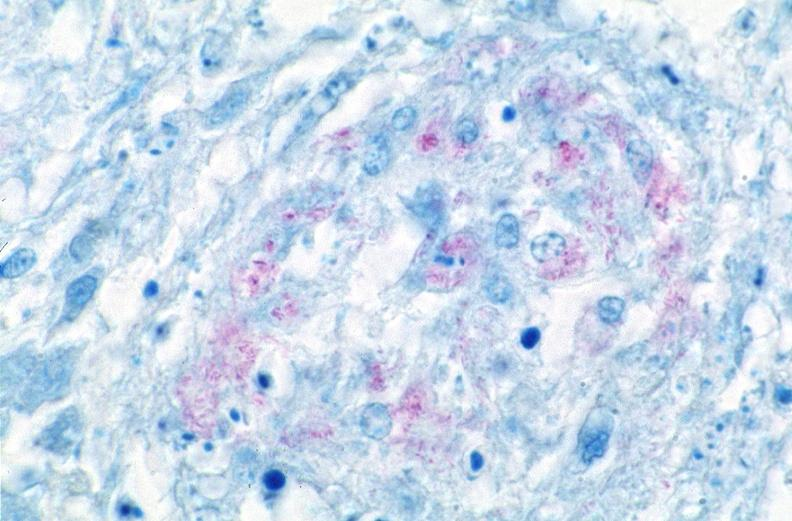what does this image show?
Answer the question using a single word or phrase. Lung 